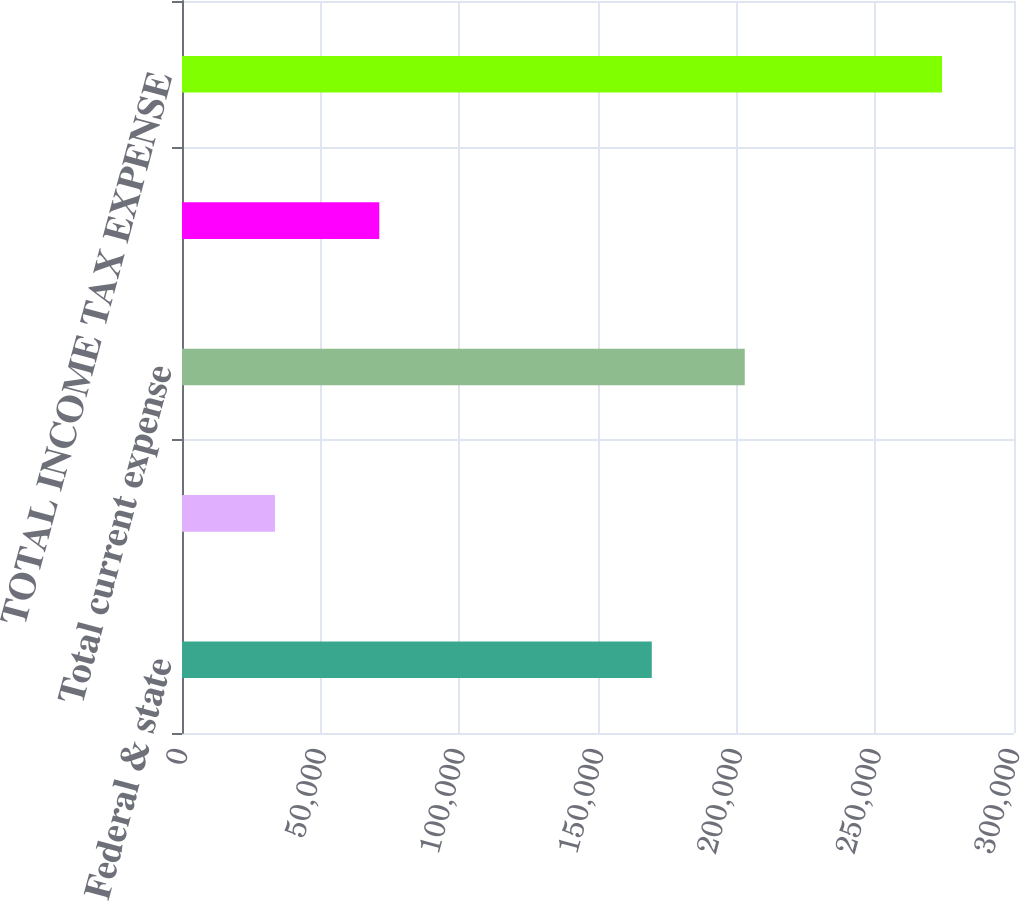<chart> <loc_0><loc_0><loc_500><loc_500><bar_chart><fcel>Federal & state<fcel>Foreign<fcel>Total current expense<fcel>Total deferred expense (benefi<fcel>TOTAL INCOME TAX EXPENSE<nl><fcel>169394<fcel>33520<fcel>202914<fcel>71132<fcel>274046<nl></chart> 